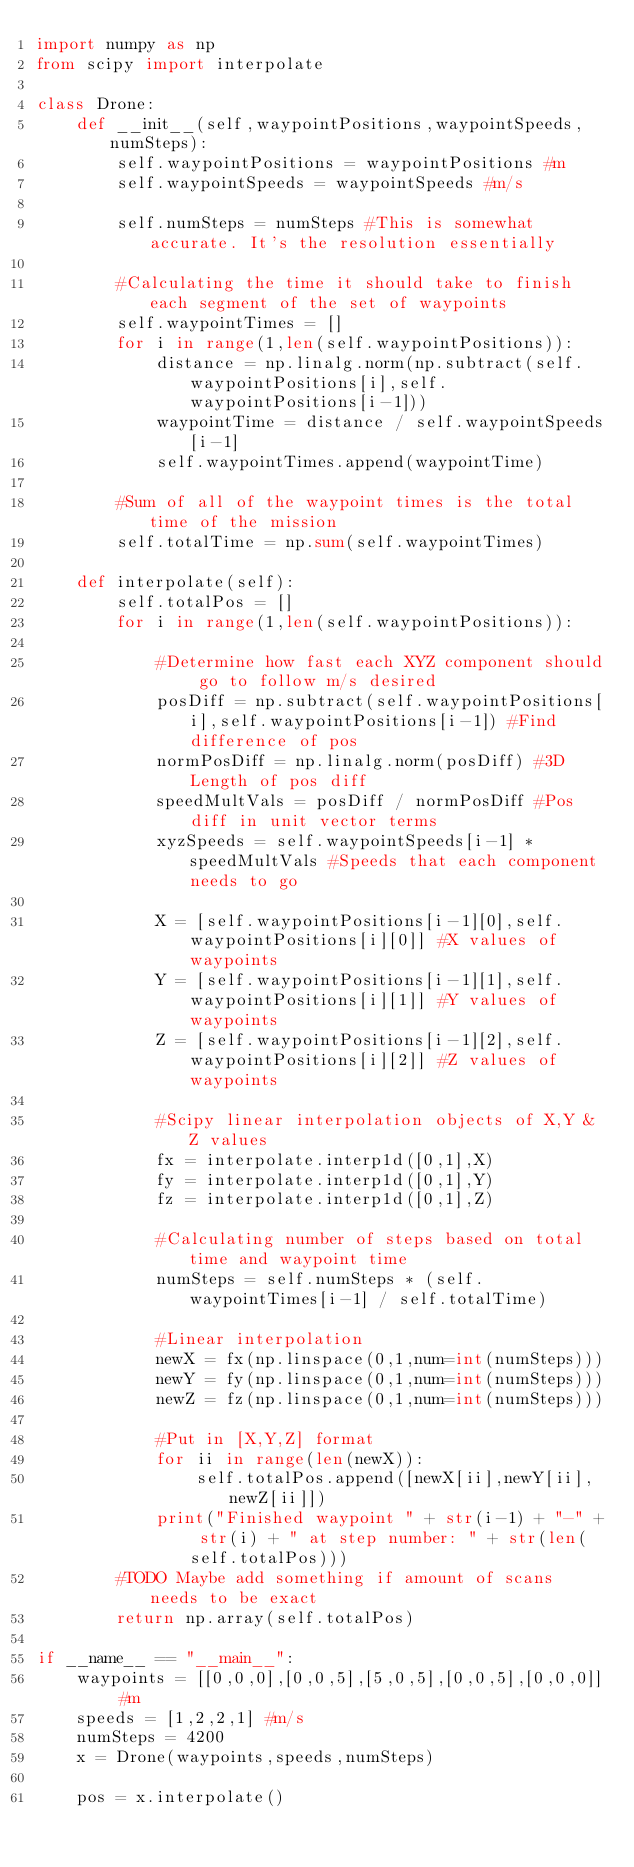<code> <loc_0><loc_0><loc_500><loc_500><_Python_>import numpy as np
from scipy import interpolate

class Drone:
    def __init__(self,waypointPositions,waypointSpeeds,numSteps):
        self.waypointPositions = waypointPositions #m
        self.waypointSpeeds = waypointSpeeds #m/s
        
        self.numSteps = numSteps #This is somewhat accurate. It's the resolution essentially

        #Calculating the time it should take to finish each segment of the set of waypoints
        self.waypointTimes = []
        for i in range(1,len(self.waypointPositions)):
            distance = np.linalg.norm(np.subtract(self.waypointPositions[i],self.waypointPositions[i-1]))
            waypointTime = distance / self.waypointSpeeds[i-1]
            self.waypointTimes.append(waypointTime)
       
        #Sum of all of the waypoint times is the total time of the mission
        self.totalTime = np.sum(self.waypointTimes)

    def interpolate(self):
        self.totalPos = []
        for i in range(1,len(self.waypointPositions)):
            
            #Determine how fast each XYZ component should go to follow m/s desired
            posDiff = np.subtract(self.waypointPositions[i],self.waypointPositions[i-1]) #Find difference of pos
            normPosDiff = np.linalg.norm(posDiff) #3D Length of pos diff
            speedMultVals = posDiff / normPosDiff #Pos diff in unit vector terms
            xyzSpeeds = self.waypointSpeeds[i-1] * speedMultVals #Speeds that each component needs to go

            X = [self.waypointPositions[i-1][0],self.waypointPositions[i][0]] #X values of waypoints
            Y = [self.waypointPositions[i-1][1],self.waypointPositions[i][1]] #Y values of waypoints
            Z = [self.waypointPositions[i-1][2],self.waypointPositions[i][2]] #Z values of waypoints
            
            #Scipy linear interpolation objects of X,Y & Z values
            fx = interpolate.interp1d([0,1],X)
            fy = interpolate.interp1d([0,1],Y)
            fz = interpolate.interp1d([0,1],Z)
    
            #Calculating number of steps based on total time and waypoint time
            numSteps = self.numSteps * (self.waypointTimes[i-1] / self.totalTime)

            #Linear interpolation
            newX = fx(np.linspace(0,1,num=int(numSteps)))
            newY = fy(np.linspace(0,1,num=int(numSteps)))
            newZ = fz(np.linspace(0,1,num=int(numSteps)))

            #Put in [X,Y,Z] format
            for ii in range(len(newX)):
                self.totalPos.append([newX[ii],newY[ii],newZ[ii]])
            print("Finished waypoint " + str(i-1) + "-" + str(i) + " at step number: " + str(len(self.totalPos)))
        #TODO Maybe add something if amount of scans needs to be exact
        return np.array(self.totalPos)

if __name__ == "__main__":
    waypoints = [[0,0,0],[0,0,5],[5,0,5],[0,0,5],[0,0,0]] #m
    speeds = [1,2,2,1] #m/s
    numSteps = 4200
    x = Drone(waypoints,speeds,numSteps)

    pos = x.interpolate()
</code> 